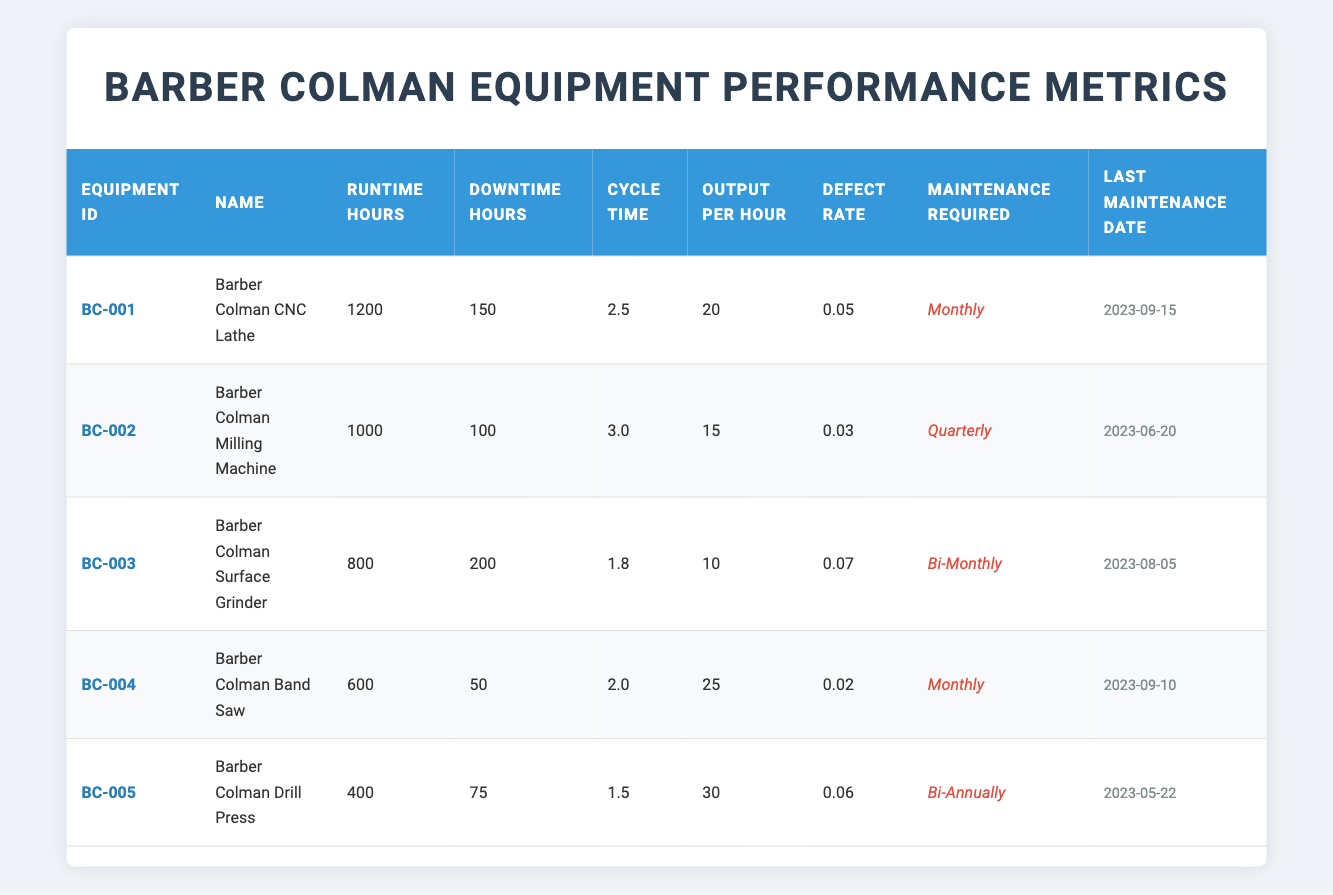What is the output per hour for the Barber Colman CNC Lathe? The output per hour for the Barber Colman CNC Lathe is listed directly in the table under the Output Per Hour column, which shows 20.
Answer: 20 Which Barber Colman equipment has the highest defect rate? By reviewing the Defect Rate column, I compare each equipment's rate. The Barber Colman Surface Grinder has a defect rate of 0.07, which is the highest compared to all others.
Answer: Barber Colman Surface Grinder How many total runtime hours do all pieces of Barber Colman equipment have combined? I need to add the Runtime Hours from each piece of equipment: 1200 + 1000 + 800 + 600 + 400 = 4000 hours.
Answer: 4000 Is the Barber Colman Band Saw scheduled for monthly maintenance? Looking at the Maintenance Required column, it states "Monthly" for the Barber Colman Band Saw, which confirms the scheduling is indeed monthly.
Answer: Yes What is the average cycle time of the Barber Colman machinery? I first sum the Cycle Time values: 2.5 + 3.0 + 1.8 + 2.0 + 1.5 = 11.8. Then, I divide by the total number of equipment (5) to find the average: 11.8 / 5 = 2.36.
Answer: 2.36 Does the Barber Colman Drill Press have a lower output per hour than the Barber Colman Milling Machine? The Output Per Hour for the Drill Press is 30 and for the Milling Machine it is 15. 30 is greater than 15, therefore, the Drill Press does not have a lower output.
Answer: No What is the total downtime across all Barber Colman equipment? I will sum the Downtime Hours: 150 + 100 + 200 + 50 + 75 = 575 hours. This total indicates the amount of downtime for all machines.
Answer: 575 Which piece of equipment last maintained on 2023-09-15? By checking the Last Maintenance Date for each piece of equipment, I find that the equipment with that date is the Barber Colman CNC Lathe.
Answer: Barber Colman CNC Lathe What is the only piece of Barber Colman equipment that requires maintenance bi-annually? Reviewing the Maintenance Required column, the Barber Colman Drill Press is specifically marked as needing Bi-Annually maintenance.
Answer: Barber Colman Drill Press 